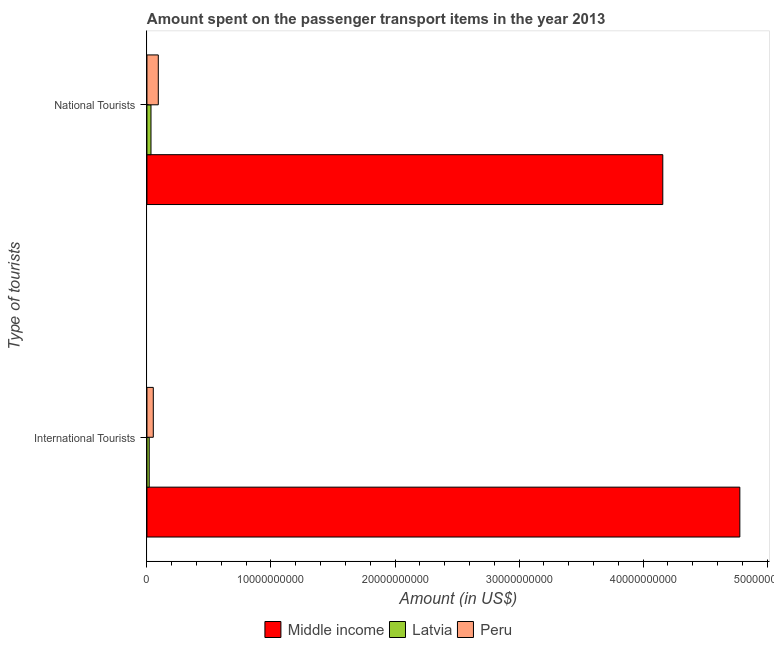Are the number of bars per tick equal to the number of legend labels?
Give a very brief answer. Yes. How many bars are there on the 2nd tick from the top?
Your answer should be compact. 3. How many bars are there on the 1st tick from the bottom?
Give a very brief answer. 3. What is the label of the 2nd group of bars from the top?
Your answer should be very brief. International Tourists. What is the amount spent on transport items of international tourists in Middle income?
Offer a very short reply. 4.78e+1. Across all countries, what is the maximum amount spent on transport items of national tourists?
Keep it short and to the point. 4.16e+1. Across all countries, what is the minimum amount spent on transport items of international tourists?
Provide a succinct answer. 1.84e+08. In which country was the amount spent on transport items of national tourists maximum?
Keep it short and to the point. Middle income. In which country was the amount spent on transport items of international tourists minimum?
Your answer should be compact. Latvia. What is the total amount spent on transport items of national tourists in the graph?
Provide a short and direct response. 4.28e+1. What is the difference between the amount spent on transport items of international tourists in Latvia and that in Peru?
Ensure brevity in your answer.  -3.29e+08. What is the difference between the amount spent on transport items of international tourists in Latvia and the amount spent on transport items of national tourists in Middle income?
Your answer should be very brief. -4.14e+1. What is the average amount spent on transport items of international tourists per country?
Offer a very short reply. 1.62e+1. What is the difference between the amount spent on transport items of international tourists and amount spent on transport items of national tourists in Middle income?
Keep it short and to the point. 6.21e+09. In how many countries, is the amount spent on transport items of international tourists greater than 28000000000 US$?
Provide a short and direct response. 1. What is the ratio of the amount spent on transport items of national tourists in Peru to that in Middle income?
Provide a short and direct response. 0.02. Is the amount spent on transport items of international tourists in Latvia less than that in Middle income?
Give a very brief answer. Yes. In how many countries, is the amount spent on transport items of national tourists greater than the average amount spent on transport items of national tourists taken over all countries?
Provide a succinct answer. 1. What does the 1st bar from the bottom in National Tourists represents?
Ensure brevity in your answer.  Middle income. How many bars are there?
Offer a very short reply. 6. Are all the bars in the graph horizontal?
Your answer should be very brief. Yes. Are the values on the major ticks of X-axis written in scientific E-notation?
Your response must be concise. No. Where does the legend appear in the graph?
Keep it short and to the point. Bottom center. How many legend labels are there?
Provide a short and direct response. 3. What is the title of the graph?
Provide a succinct answer. Amount spent on the passenger transport items in the year 2013. What is the label or title of the X-axis?
Provide a short and direct response. Amount (in US$). What is the label or title of the Y-axis?
Ensure brevity in your answer.  Type of tourists. What is the Amount (in US$) in Middle income in International Tourists?
Ensure brevity in your answer.  4.78e+1. What is the Amount (in US$) of Latvia in International Tourists?
Provide a short and direct response. 1.84e+08. What is the Amount (in US$) of Peru in International Tourists?
Offer a very short reply. 5.13e+08. What is the Amount (in US$) in Middle income in National Tourists?
Provide a short and direct response. 4.16e+1. What is the Amount (in US$) of Latvia in National Tourists?
Your response must be concise. 3.26e+08. What is the Amount (in US$) in Peru in National Tourists?
Your answer should be compact. 9.16e+08. Across all Type of tourists, what is the maximum Amount (in US$) in Middle income?
Keep it short and to the point. 4.78e+1. Across all Type of tourists, what is the maximum Amount (in US$) in Latvia?
Provide a succinct answer. 3.26e+08. Across all Type of tourists, what is the maximum Amount (in US$) in Peru?
Ensure brevity in your answer.  9.16e+08. Across all Type of tourists, what is the minimum Amount (in US$) of Middle income?
Give a very brief answer. 4.16e+1. Across all Type of tourists, what is the minimum Amount (in US$) in Latvia?
Your answer should be compact. 1.84e+08. Across all Type of tourists, what is the minimum Amount (in US$) in Peru?
Ensure brevity in your answer.  5.13e+08. What is the total Amount (in US$) of Middle income in the graph?
Give a very brief answer. 8.94e+1. What is the total Amount (in US$) in Latvia in the graph?
Keep it short and to the point. 5.10e+08. What is the total Amount (in US$) of Peru in the graph?
Your answer should be compact. 1.43e+09. What is the difference between the Amount (in US$) in Middle income in International Tourists and that in National Tourists?
Make the answer very short. 6.21e+09. What is the difference between the Amount (in US$) of Latvia in International Tourists and that in National Tourists?
Your response must be concise. -1.42e+08. What is the difference between the Amount (in US$) in Peru in International Tourists and that in National Tourists?
Provide a succinct answer. -4.03e+08. What is the difference between the Amount (in US$) in Middle income in International Tourists and the Amount (in US$) in Latvia in National Tourists?
Provide a succinct answer. 4.75e+1. What is the difference between the Amount (in US$) of Middle income in International Tourists and the Amount (in US$) of Peru in National Tourists?
Offer a terse response. 4.69e+1. What is the difference between the Amount (in US$) in Latvia in International Tourists and the Amount (in US$) in Peru in National Tourists?
Your response must be concise. -7.32e+08. What is the average Amount (in US$) in Middle income per Type of tourists?
Offer a very short reply. 4.47e+1. What is the average Amount (in US$) of Latvia per Type of tourists?
Offer a very short reply. 2.55e+08. What is the average Amount (in US$) in Peru per Type of tourists?
Your answer should be very brief. 7.14e+08. What is the difference between the Amount (in US$) in Middle income and Amount (in US$) in Latvia in International Tourists?
Keep it short and to the point. 4.76e+1. What is the difference between the Amount (in US$) of Middle income and Amount (in US$) of Peru in International Tourists?
Your response must be concise. 4.73e+1. What is the difference between the Amount (in US$) in Latvia and Amount (in US$) in Peru in International Tourists?
Give a very brief answer. -3.29e+08. What is the difference between the Amount (in US$) of Middle income and Amount (in US$) of Latvia in National Tourists?
Your answer should be compact. 4.13e+1. What is the difference between the Amount (in US$) in Middle income and Amount (in US$) in Peru in National Tourists?
Your answer should be compact. 4.07e+1. What is the difference between the Amount (in US$) of Latvia and Amount (in US$) of Peru in National Tourists?
Give a very brief answer. -5.90e+08. What is the ratio of the Amount (in US$) in Middle income in International Tourists to that in National Tourists?
Offer a terse response. 1.15. What is the ratio of the Amount (in US$) in Latvia in International Tourists to that in National Tourists?
Your answer should be very brief. 0.56. What is the ratio of the Amount (in US$) in Peru in International Tourists to that in National Tourists?
Provide a succinct answer. 0.56. What is the difference between the highest and the second highest Amount (in US$) of Middle income?
Keep it short and to the point. 6.21e+09. What is the difference between the highest and the second highest Amount (in US$) in Latvia?
Your answer should be very brief. 1.42e+08. What is the difference between the highest and the second highest Amount (in US$) of Peru?
Ensure brevity in your answer.  4.03e+08. What is the difference between the highest and the lowest Amount (in US$) in Middle income?
Offer a terse response. 6.21e+09. What is the difference between the highest and the lowest Amount (in US$) in Latvia?
Make the answer very short. 1.42e+08. What is the difference between the highest and the lowest Amount (in US$) of Peru?
Make the answer very short. 4.03e+08. 